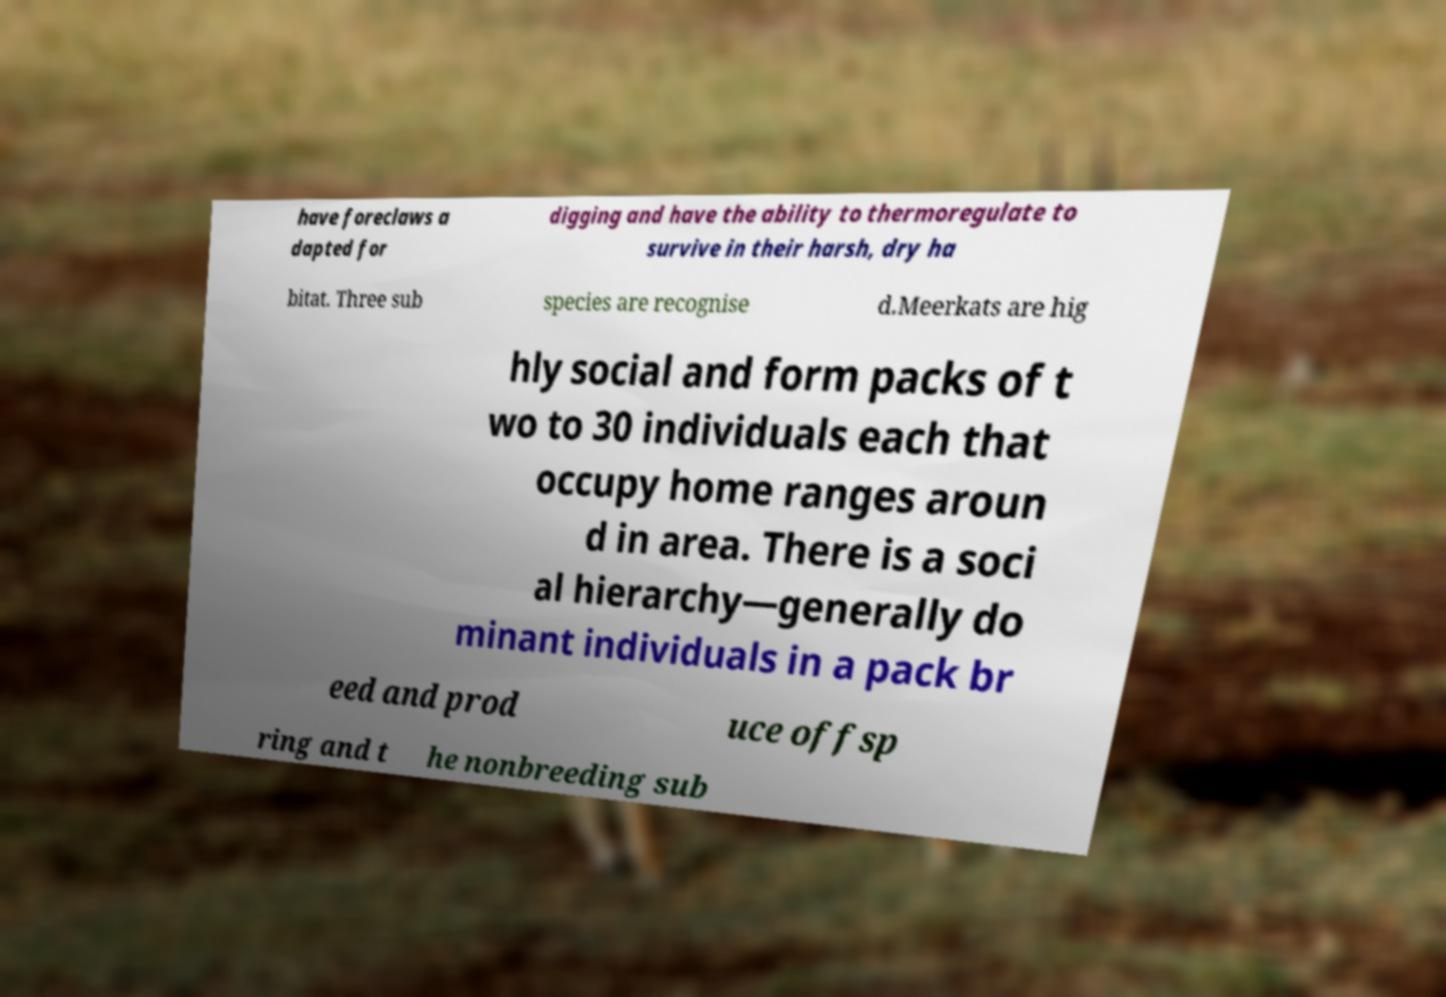Can you read and provide the text displayed in the image?This photo seems to have some interesting text. Can you extract and type it out for me? have foreclaws a dapted for digging and have the ability to thermoregulate to survive in their harsh, dry ha bitat. Three sub species are recognise d.Meerkats are hig hly social and form packs of t wo to 30 individuals each that occupy home ranges aroun d in area. There is a soci al hierarchy—generally do minant individuals in a pack br eed and prod uce offsp ring and t he nonbreeding sub 